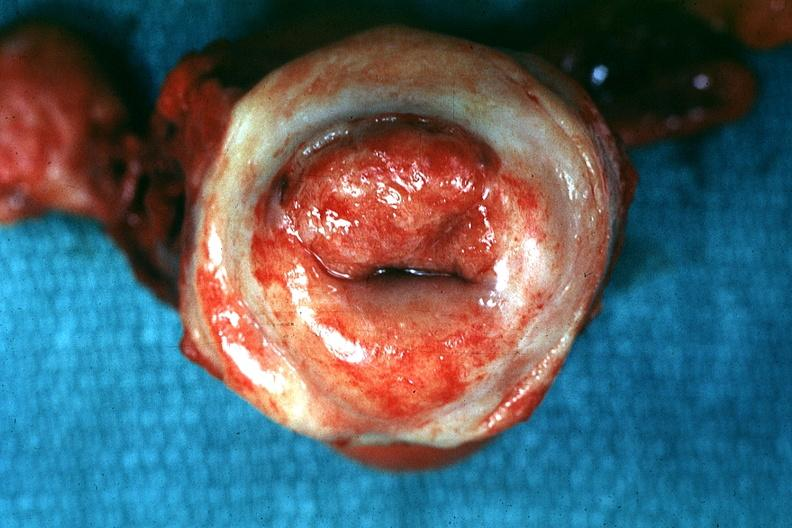what does this image show?
Answer the question using a single word or phrase. Excellent close-up of thickened 